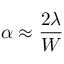Convert formula to latex. <formula><loc_0><loc_0><loc_500><loc_500>\alpha \approx { \frac { 2 \lambda } { W } }</formula> 